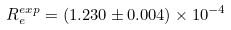<formula> <loc_0><loc_0><loc_500><loc_500>R _ { e } ^ { e x p } = ( 1 . 2 3 0 \pm 0 . 0 0 4 ) \times 1 0 ^ { - 4 }</formula> 